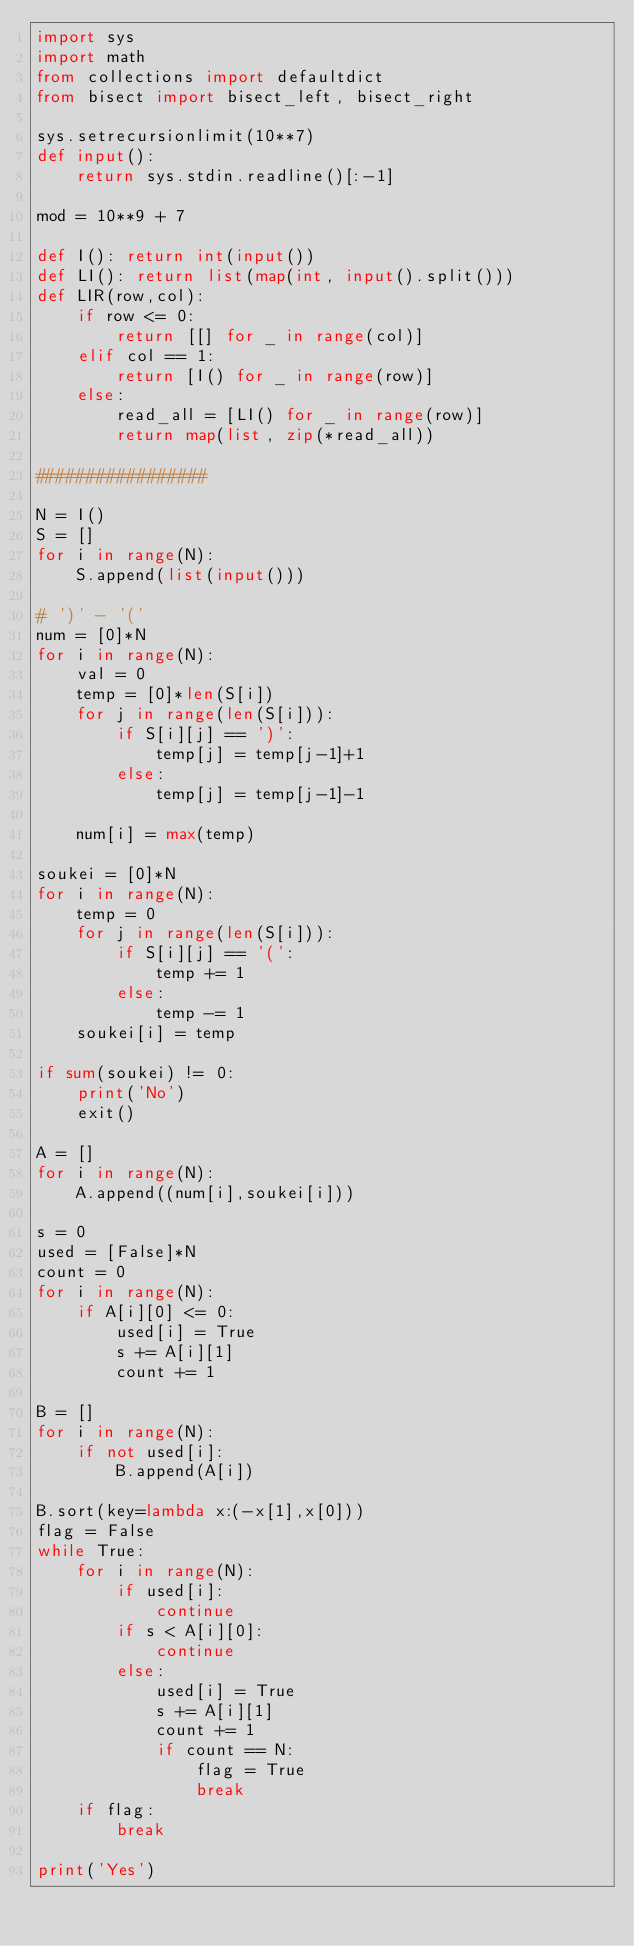Convert code to text. <code><loc_0><loc_0><loc_500><loc_500><_Python_>import sys
import math
from collections import defaultdict
from bisect import bisect_left, bisect_right

sys.setrecursionlimit(10**7)
def input():
    return sys.stdin.readline()[:-1]

mod = 10**9 + 7

def I(): return int(input())
def LI(): return list(map(int, input().split()))
def LIR(row,col):
    if row <= 0:
        return [[] for _ in range(col)]
    elif col == 1:
        return [I() for _ in range(row)]
    else:
        read_all = [LI() for _ in range(row)]
        return map(list, zip(*read_all))

#################

N = I()
S = []
for i in range(N):
    S.append(list(input()))

# ')' - '('
num = [0]*N
for i in range(N):
    val = 0
    temp = [0]*len(S[i])
    for j in range(len(S[i])):
        if S[i][j] == ')':
            temp[j] = temp[j-1]+1
        else:
            temp[j] = temp[j-1]-1

    num[i] = max(temp)

soukei = [0]*N
for i in range(N):
    temp = 0
    for j in range(len(S[i])):
        if S[i][j] == '(':
            temp += 1
        else:
            temp -= 1
    soukei[i] = temp

if sum(soukei) != 0:
    print('No')
    exit()

A = []
for i in range(N):
    A.append((num[i],soukei[i]))

s = 0
used = [False]*N
count = 0
for i in range(N):
    if A[i][0] <= 0:
        used[i] = True
        s += A[i][1]
        count += 1

B = []
for i in range(N):
    if not used[i]:
        B.append(A[i])

B.sort(key=lambda x:(-x[1],x[0]))
flag = False
while True:
    for i in range(N):
        if used[i]:
            continue
        if s < A[i][0]:
            continue
        else:
            used[i] = True
            s += A[i][1]
            count += 1
            if count == N:
                flag = True
                break
    if flag:
        break
    
print('Yes')</code> 